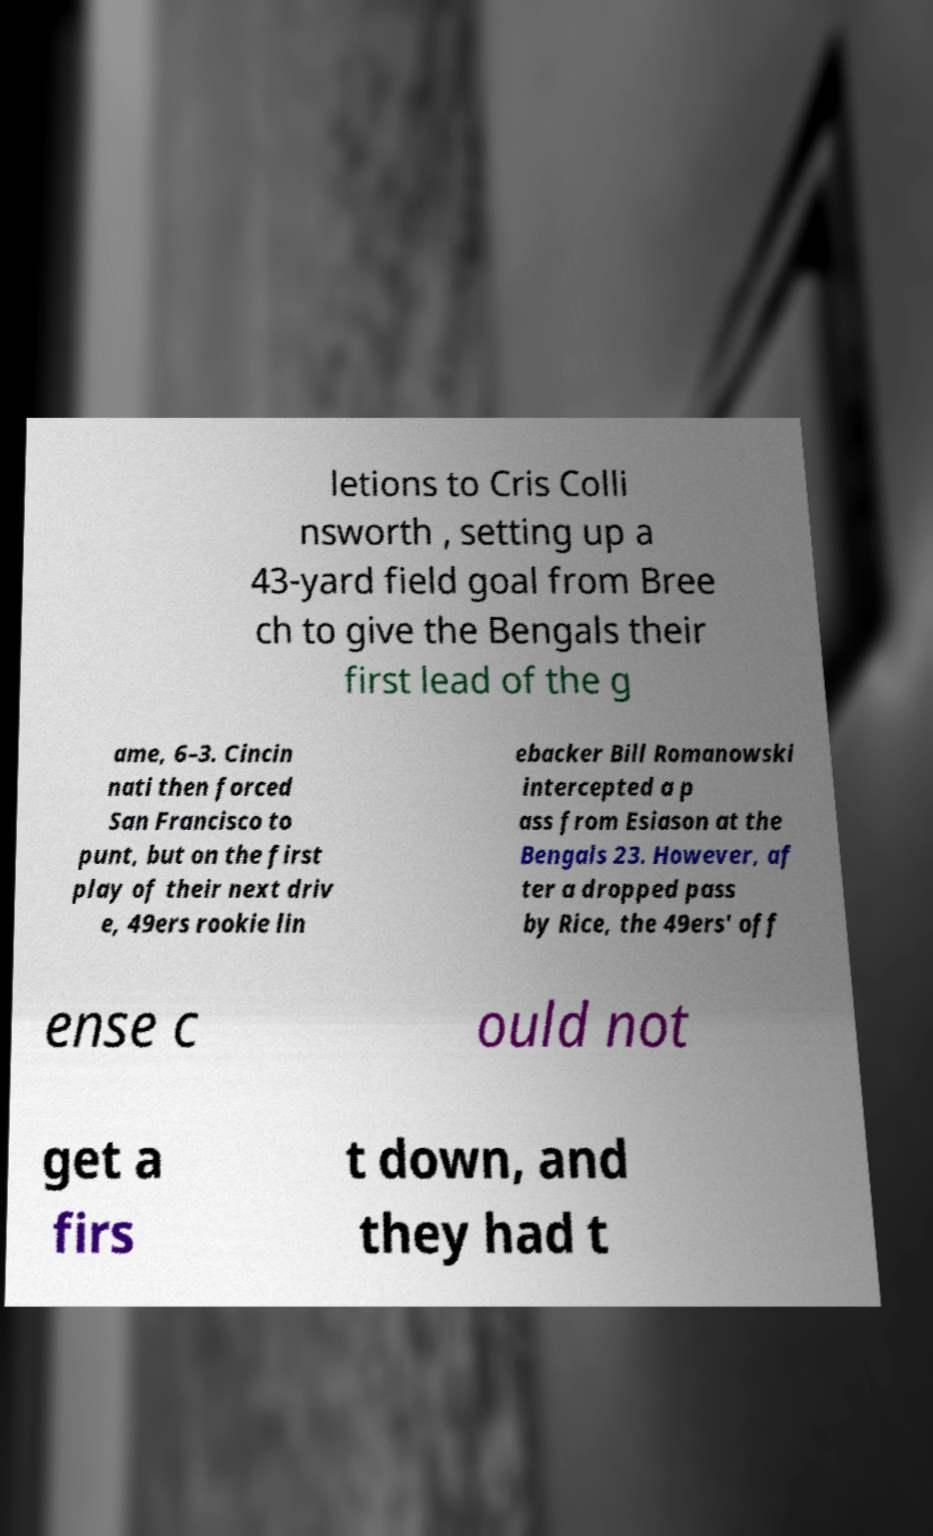Please read and relay the text visible in this image. What does it say? letions to Cris Colli nsworth , setting up a 43-yard field goal from Bree ch to give the Bengals their first lead of the g ame, 6–3. Cincin nati then forced San Francisco to punt, but on the first play of their next driv e, 49ers rookie lin ebacker Bill Romanowski intercepted a p ass from Esiason at the Bengals 23. However, af ter a dropped pass by Rice, the 49ers' off ense c ould not get a firs t down, and they had t 